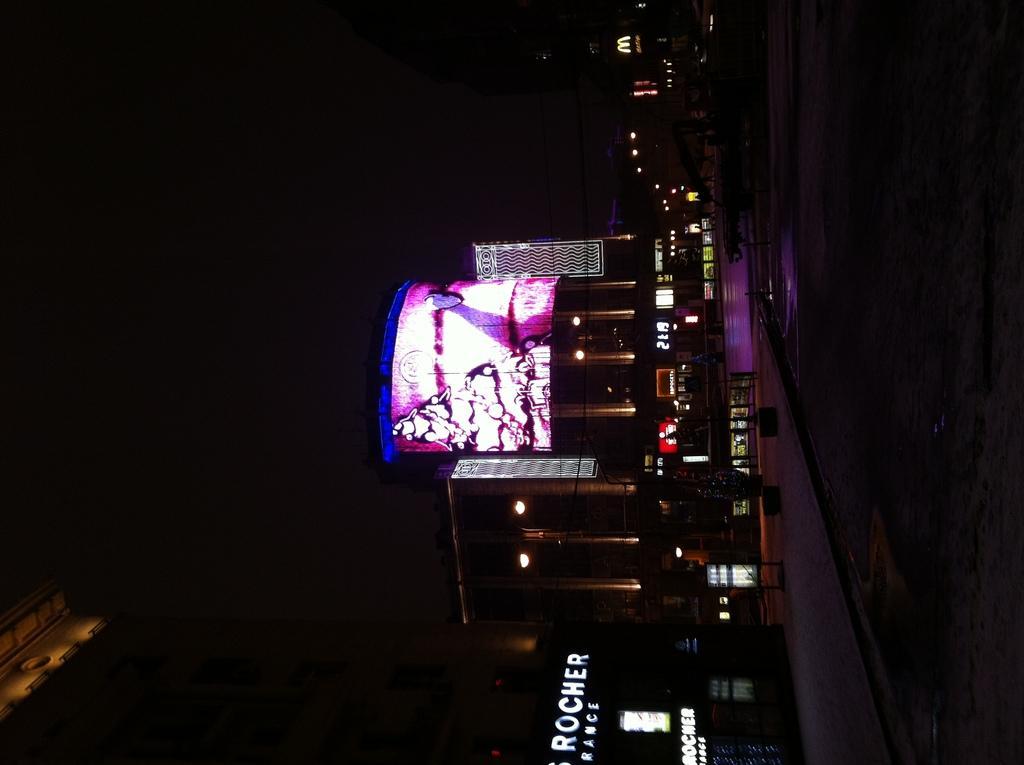Describe this image in one or two sentences. In the given picture, we can see the building included with the screen and an electronic watch, after that we can see a few lights and the store and finally we can see the road. 